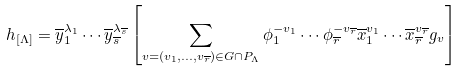<formula> <loc_0><loc_0><loc_500><loc_500>h _ { [ \Lambda ] } = \overline { y } _ { 1 } ^ { \lambda _ { 1 } } \cdots \overline { y } _ { \overline { s } } ^ { \lambda _ { \overline { s } } } \left [ \sum _ { v = ( v _ { 1 } , \dots , v _ { \overline { r } } ) \in G \cap P _ { \Lambda } } \phi _ { 1 } ^ { - v _ { 1 } } \cdots \phi _ { \overline { r } } ^ { - v _ { \overline { r } } } \overline { x } _ { 1 } ^ { v _ { 1 } } \cdots \overline { x } _ { \overline { r } } ^ { v _ { \overline { r } } } g _ { v } \right ]</formula> 